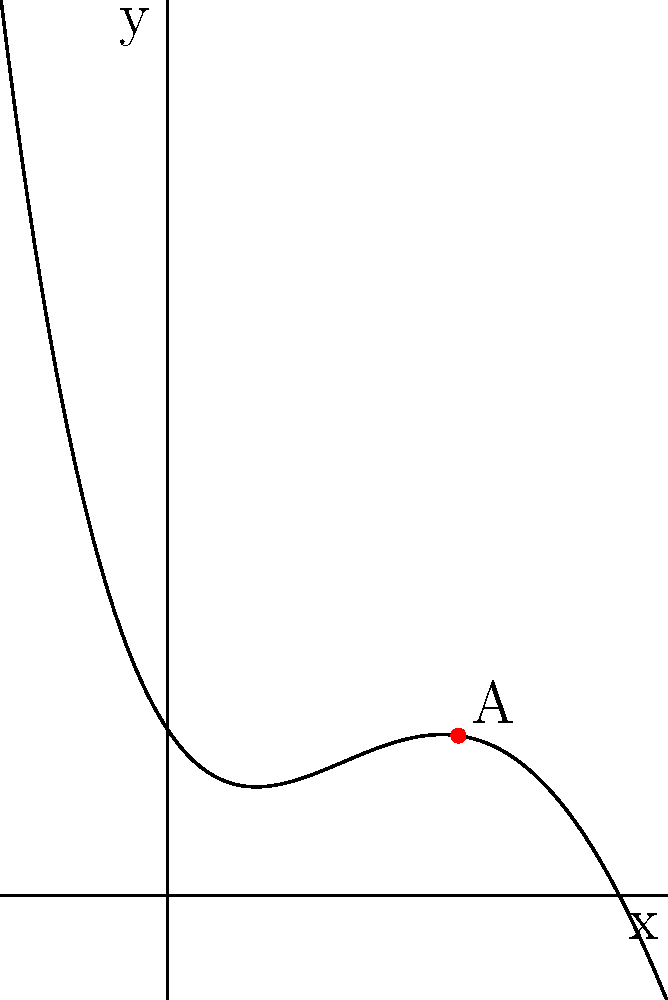The curvature of a custom-designed grand staircase in your luxurious mansion can be modeled by the polynomial function $f(x) = 0.01x^4 - 0.2x^3 + x^2 - 1.5x + 2$, where $x$ is the horizontal distance in meters and $f(x)$ is the height in meters. At point A $(3.5, f(3.5))$, what is the rate of change of the slope (second derivative) of the staircase? To find the rate of change of the slope at point A, we need to calculate the second derivative of the function $f(x)$ at $x = 3.5$. Let's proceed step by step:

1) First, let's find the first derivative $f'(x)$:
   $f'(x) = 0.04x^3 - 0.6x^2 + 2x - 1.5$

2) Now, let's find the second derivative $f''(x)$:
   $f''(x) = 0.12x^2 - 1.2x + 2$

3) We need to evaluate $f''(x)$ at $x = 3.5$:
   $f''(3.5) = 0.12(3.5)^2 - 1.2(3.5) + 2$
   
4) Let's calculate:
   $f''(3.5) = 0.12(12.25) - 4.2 + 2$
   $f''(3.5) = 1.47 - 4.2 + 2$
   $f''(3.5) = -0.73$

Therefore, the rate of change of the slope (second derivative) at point A is -0.73 m^-1.
Answer: -0.73 m^-1 